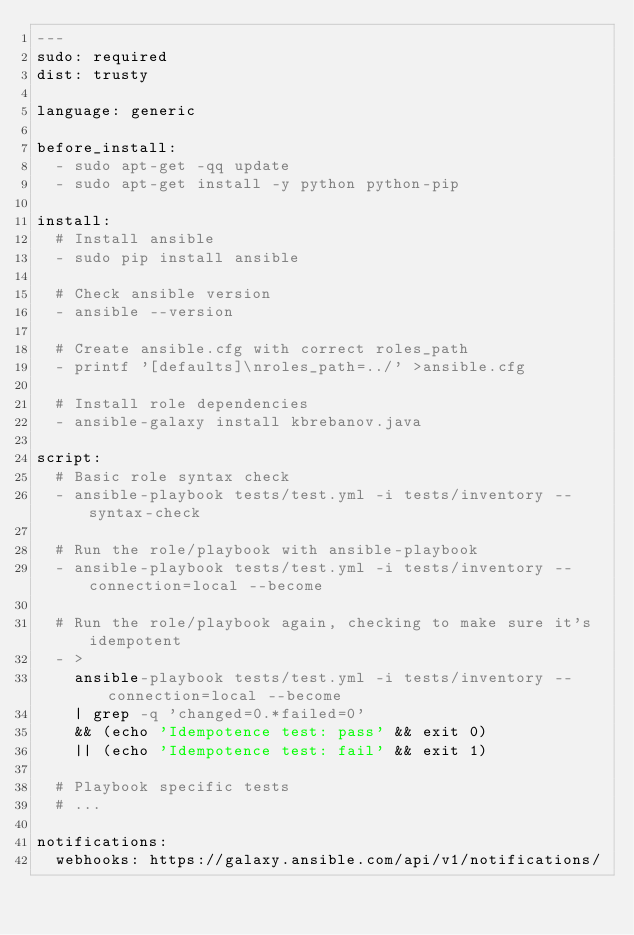Convert code to text. <code><loc_0><loc_0><loc_500><loc_500><_YAML_>---
sudo: required
dist: trusty

language: generic

before_install:
  - sudo apt-get -qq update
  - sudo apt-get install -y python python-pip

install:
  # Install ansible
  - sudo pip install ansible

  # Check ansible version
  - ansible --version

  # Create ansible.cfg with correct roles_path
  - printf '[defaults]\nroles_path=../' >ansible.cfg

  # Install role dependencies
  - ansible-galaxy install kbrebanov.java

script:
  # Basic role syntax check
  - ansible-playbook tests/test.yml -i tests/inventory --syntax-check

  # Run the role/playbook with ansible-playbook
  - ansible-playbook tests/test.yml -i tests/inventory --connection=local --become

  # Run the role/playbook again, checking to make sure it's idempotent
  - >
    ansible-playbook tests/test.yml -i tests/inventory --connection=local --become
    | grep -q 'changed=0.*failed=0'
    && (echo 'Idempotence test: pass' && exit 0)
    || (echo 'Idempotence test: fail' && exit 1)

  # Playbook specific tests
  # ...

notifications:
  webhooks: https://galaxy.ansible.com/api/v1/notifications/
</code> 